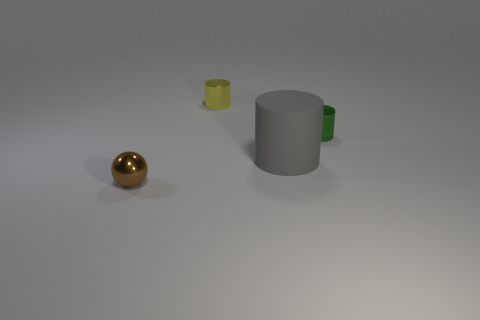How big is the metallic thing that is both in front of the yellow cylinder and on the left side of the big matte cylinder?
Your response must be concise. Small. Are there fewer tiny yellow metallic cylinders that are on the right side of the gray thing than tiny green rubber balls?
Give a very brief answer. No. There is a brown object that is made of the same material as the small green thing; what shape is it?
Give a very brief answer. Sphere. Are the green thing and the brown thing made of the same material?
Provide a short and direct response. Yes. Is the number of small yellow things that are to the left of the green metallic object less than the number of things that are in front of the small metal ball?
Make the answer very short. No. There is a cylinder behind the metal cylinder that is right of the yellow object; what number of big things are in front of it?
Your answer should be compact. 1. The other shiny cylinder that is the same size as the yellow metallic cylinder is what color?
Give a very brief answer. Green. Are there any tiny yellow metal objects of the same shape as the big gray object?
Give a very brief answer. Yes. Is there a metal thing that is to the right of the tiny thing that is in front of the cylinder that is on the right side of the large gray matte cylinder?
Give a very brief answer. Yes. What is the shape of the green metallic thing that is the same size as the ball?
Provide a short and direct response. Cylinder. 